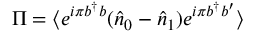<formula> <loc_0><loc_0><loc_500><loc_500>\Pi = \langle e ^ { i \pi b ^ { \dagger } b } ( \hat { n } _ { 0 } - \hat { n } _ { 1 } ) e ^ { i \pi b ^ { \dagger } b ^ { \prime } } \rangle</formula> 